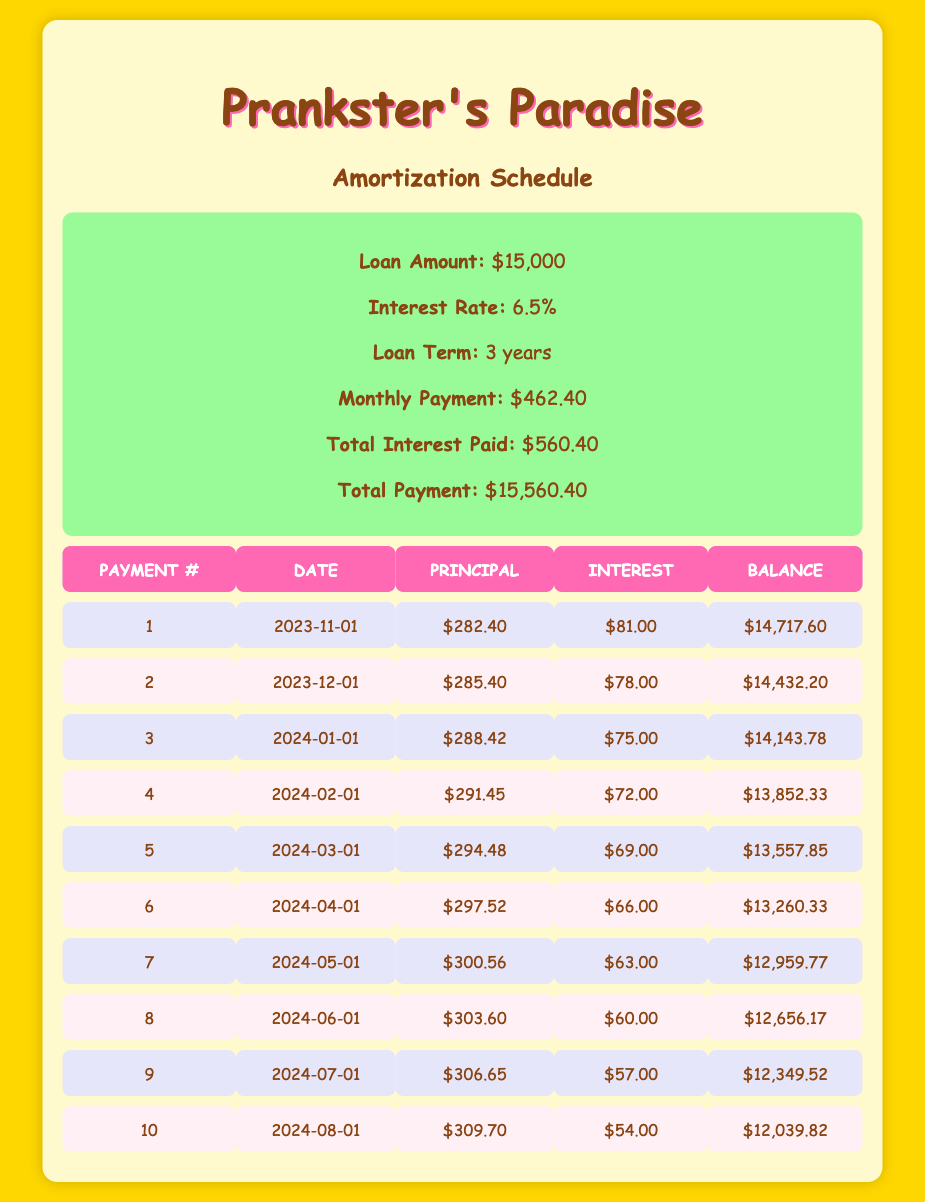What is the total loan amount for Prankster's Paradise? The loan amount is listed in the summary section of the table as $15,000.
Answer: $15,000 What is the interest rate on the loan? The interest rate is shown in the summary and is 6.5%.
Answer: 6.5% What will be the monthly payment after the first payment is made? The monthly payment is fixed and is specified in the summary as $462.40; it does not change after each payment.
Answer: $462.40 How much interest was paid in the second payment? The interest amount for the second payment is provided in the table under the second row, listed as $78.00.
Answer: $78.00 What is the total interest paid after all payments? The total interest paid is summarized in the table and is $560.40.
Answer: $560.40 Is the principal payment for the fourth payment greater than the principal payment for the first payment? The fourth payment's principal payment is $291.45, while the first payment's principal payment is $282.40, and since $291.45 is greater than $282.40, the answer is yes.
Answer: Yes What is the remaining balance after the fifth payment? The remaining balance after the fifth payment is $13,557.85, which is noted in the respective row of the table.
Answer: $13,557.85 Calculate the total principal paid after the first three payments. To find this, add the principal payments of the first three payments: $282.40 + $285.40 + $288.42 = $856.22.
Answer: $856.22 What is the average principal payment over the first ten payments? To find the average principal payment, sum the principal payments in the first ten rows and divide by 10. The sum is ($282.40 + $285.40 + $288.42 + $291.45 + $294.48 + $297.52 + $300.56 + $303.60 + $306.65 + $309.70) = $2,900.18, then divide by 10, giving an average of $290.02.
Answer: $290.02 How many payments are required to fully pay off the loan? The total loan term is three years, and since payments are made monthly, the total number of payments is 3 years times 12 months/year = 36 payments.
Answer: 36 